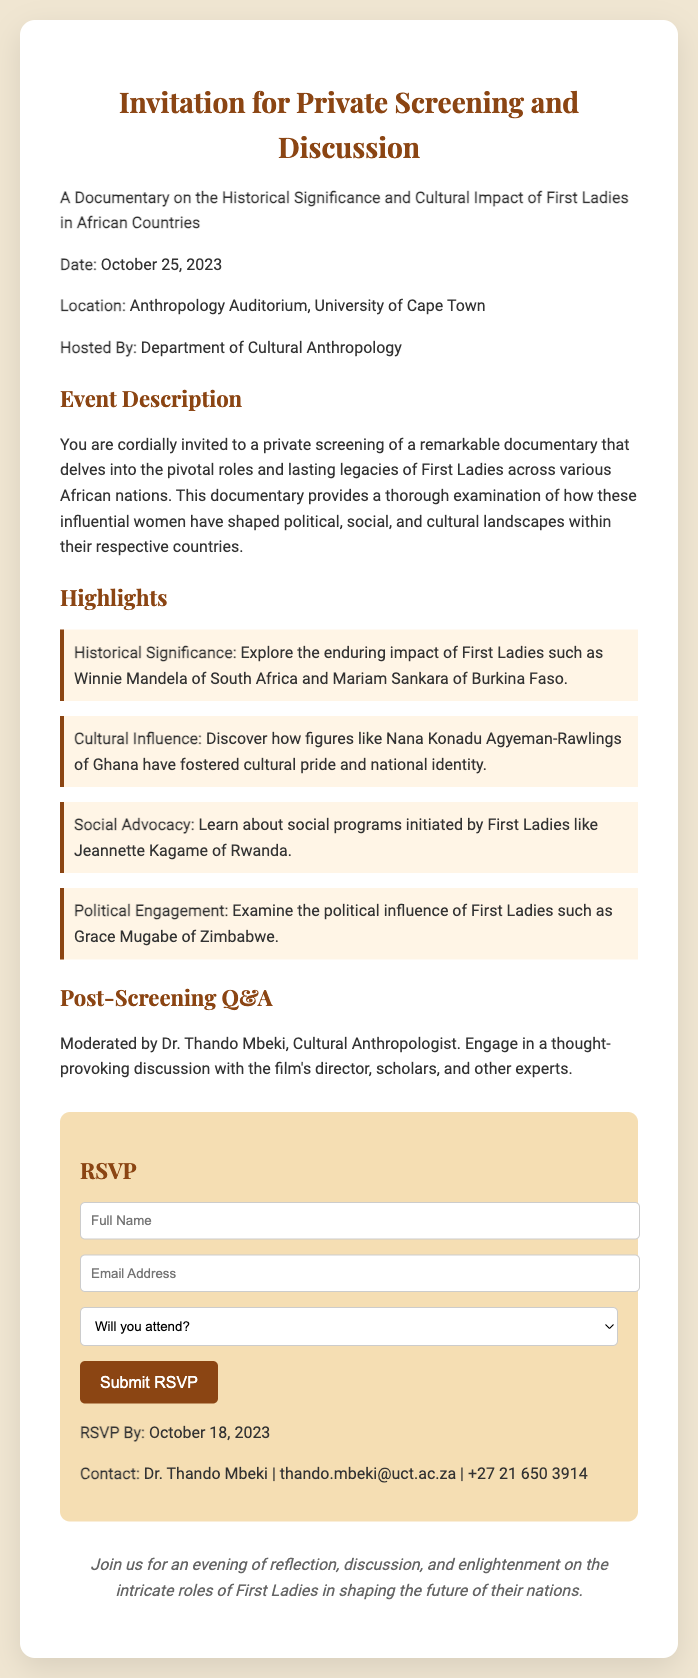What is the date of the event? The date of the event is clearly stated in the document as October 25, 2023.
Answer: October 25, 2023 Where will the screening take place? The location for the screening is provided in the document, which is the Anthropology Auditorium, University of Cape Town.
Answer: Anthropology Auditorium, University of Cape Town Who is hosting the event? The hosting entity is specified in the document as the Department of Cultural Anthropology.
Answer: Department of Cultural Anthropology What is the RSVP deadline? The document mentions that the RSVP must be submitted by October 18, 2023.
Answer: October 18, 2023 Who will moderate the post-screening Q&A? The name of the moderator for the Q&A session is mentioned as Dr. Thando Mbeki.
Answer: Dr. Thando Mbeki What is one of the highlighted topics in the documentary? The document lists multiple highlights; one example is the historical significance of First Ladies like Winnie Mandela.
Answer: Historical Significance What is required to confirm attendance? The RSVP form requires participants to select whether or not they will attend the event.
Answer: Select will you attend What type of event is this? The document describes the event as a private screening and discussion.
Answer: Private screening and discussion 